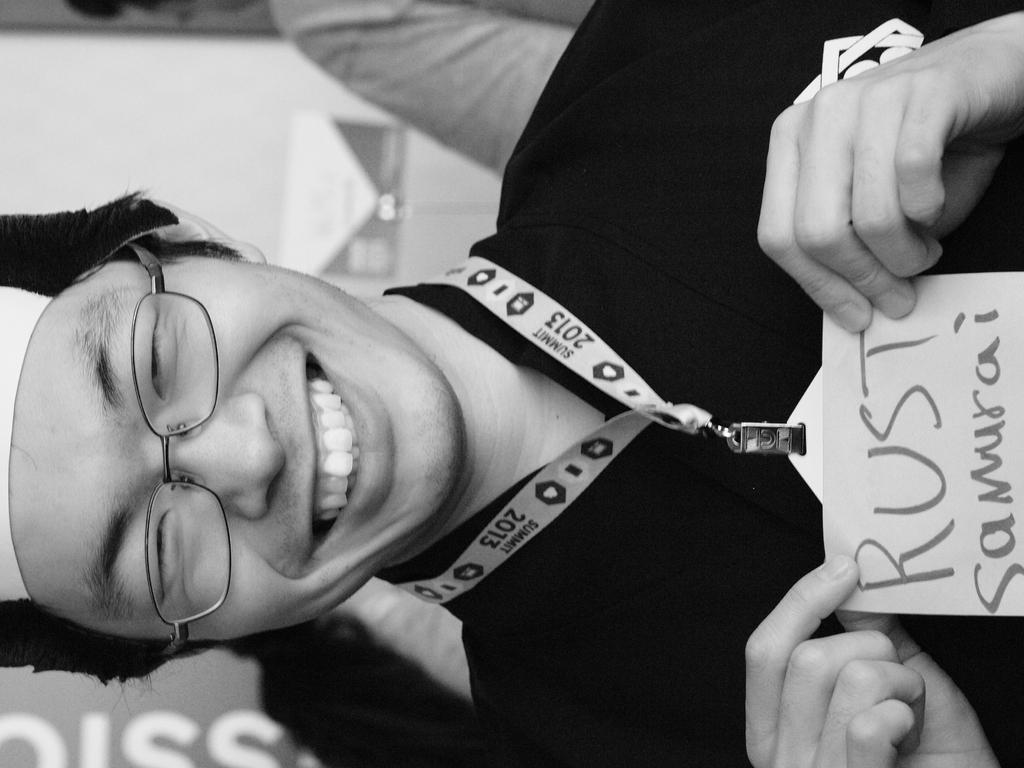Could you give a brief overview of what you see in this image? In this image I can see a man and I can see smile on her face. I can see he is wearing specs, a cap, an ID card and on it I can see something is written. I can also see this image is black and white in colour. 